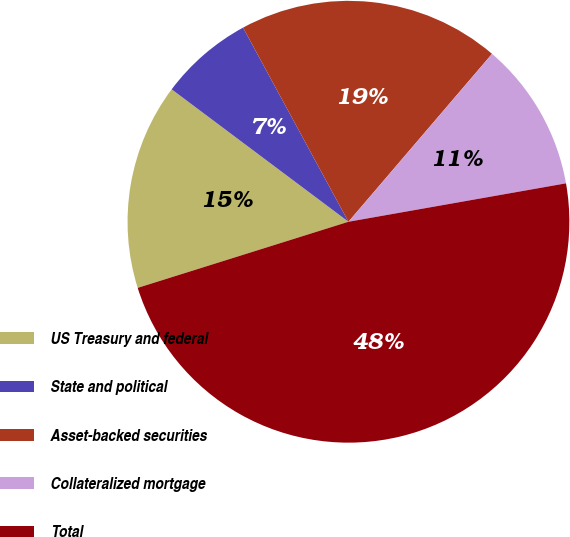<chart> <loc_0><loc_0><loc_500><loc_500><pie_chart><fcel>US Treasury and federal<fcel>State and political<fcel>Asset-backed securities<fcel>Collateralized mortgage<fcel>Total<nl><fcel>15.07%<fcel>6.85%<fcel>19.18%<fcel>10.96%<fcel>47.95%<nl></chart> 